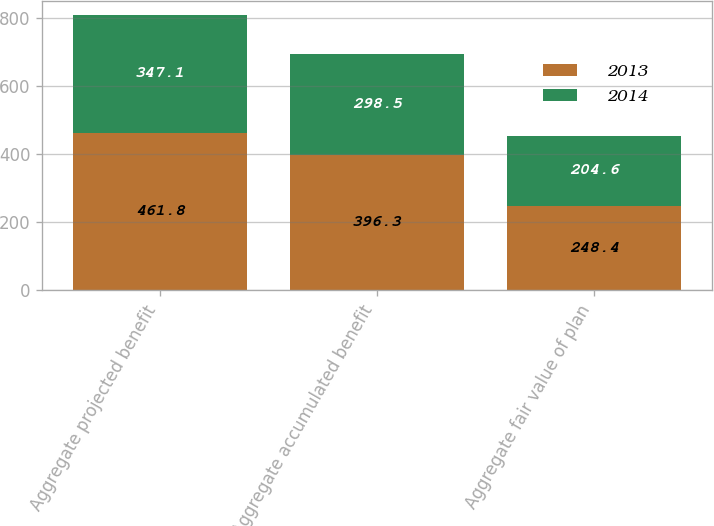Convert chart to OTSL. <chart><loc_0><loc_0><loc_500><loc_500><stacked_bar_chart><ecel><fcel>Aggregate projected benefit<fcel>Aggregate accumulated benefit<fcel>Aggregate fair value of plan<nl><fcel>2013<fcel>461.8<fcel>396.3<fcel>248.4<nl><fcel>2014<fcel>347.1<fcel>298.5<fcel>204.6<nl></chart> 